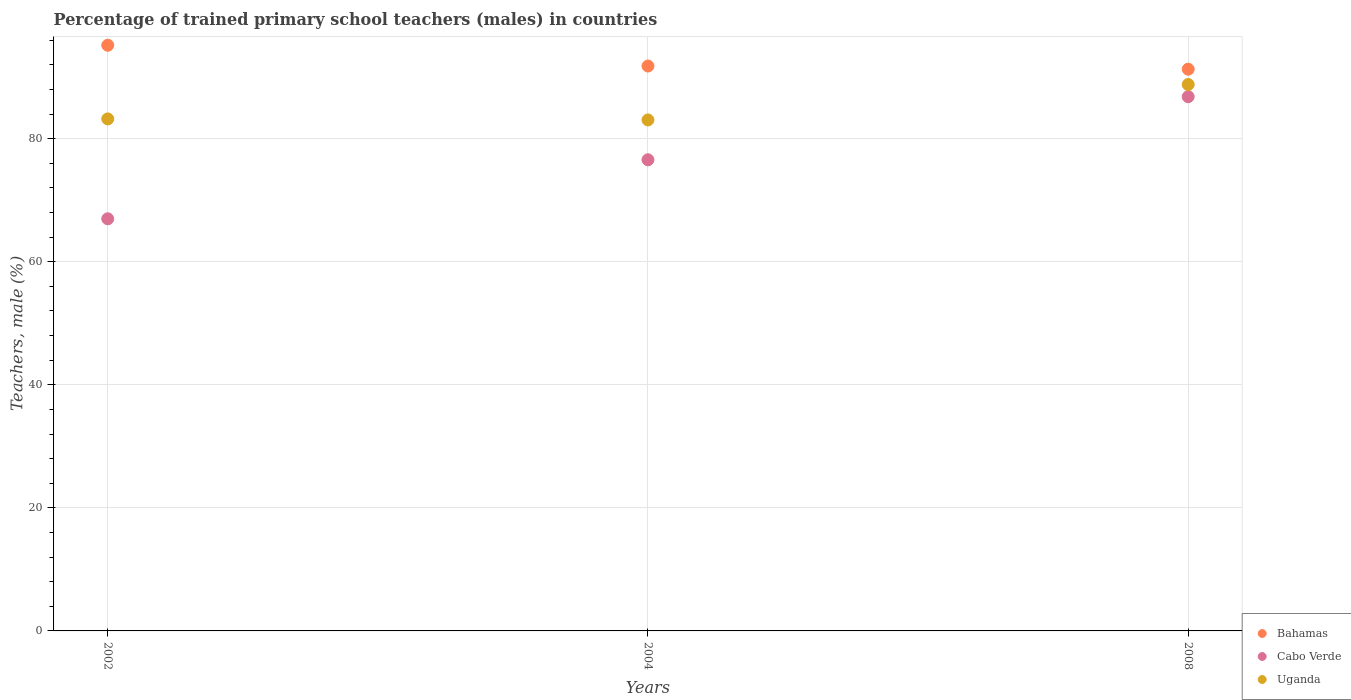What is the percentage of trained primary school teachers (males) in Cabo Verde in 2008?
Provide a succinct answer. 86.83. Across all years, what is the maximum percentage of trained primary school teachers (males) in Bahamas?
Offer a very short reply. 95.19. Across all years, what is the minimum percentage of trained primary school teachers (males) in Uganda?
Make the answer very short. 83.05. In which year was the percentage of trained primary school teachers (males) in Bahamas maximum?
Keep it short and to the point. 2002. In which year was the percentage of trained primary school teachers (males) in Uganda minimum?
Offer a very short reply. 2004. What is the total percentage of trained primary school teachers (males) in Cabo Verde in the graph?
Offer a very short reply. 230.38. What is the difference between the percentage of trained primary school teachers (males) in Uganda in 2002 and that in 2004?
Offer a terse response. 0.17. What is the difference between the percentage of trained primary school teachers (males) in Cabo Verde in 2004 and the percentage of trained primary school teachers (males) in Bahamas in 2002?
Give a very brief answer. -18.61. What is the average percentage of trained primary school teachers (males) in Cabo Verde per year?
Offer a very short reply. 76.79. In the year 2008, what is the difference between the percentage of trained primary school teachers (males) in Cabo Verde and percentage of trained primary school teachers (males) in Uganda?
Ensure brevity in your answer.  -1.98. In how many years, is the percentage of trained primary school teachers (males) in Bahamas greater than 64 %?
Ensure brevity in your answer.  3. What is the ratio of the percentage of trained primary school teachers (males) in Cabo Verde in 2002 to that in 2008?
Your response must be concise. 0.77. Is the percentage of trained primary school teachers (males) in Bahamas in 2004 less than that in 2008?
Ensure brevity in your answer.  No. Is the difference between the percentage of trained primary school teachers (males) in Cabo Verde in 2002 and 2004 greater than the difference between the percentage of trained primary school teachers (males) in Uganda in 2002 and 2004?
Provide a short and direct response. No. What is the difference between the highest and the second highest percentage of trained primary school teachers (males) in Uganda?
Provide a succinct answer. 5.59. What is the difference between the highest and the lowest percentage of trained primary school teachers (males) in Uganda?
Provide a succinct answer. 5.76. Is the sum of the percentage of trained primary school teachers (males) in Bahamas in 2002 and 2004 greater than the maximum percentage of trained primary school teachers (males) in Uganda across all years?
Offer a very short reply. Yes. Is it the case that in every year, the sum of the percentage of trained primary school teachers (males) in Cabo Verde and percentage of trained primary school teachers (males) in Bahamas  is greater than the percentage of trained primary school teachers (males) in Uganda?
Offer a very short reply. Yes. Is the percentage of trained primary school teachers (males) in Bahamas strictly greater than the percentage of trained primary school teachers (males) in Uganda over the years?
Offer a very short reply. Yes. Is the percentage of trained primary school teachers (males) in Cabo Verde strictly less than the percentage of trained primary school teachers (males) in Bahamas over the years?
Offer a very short reply. Yes. How many years are there in the graph?
Offer a very short reply. 3. What is the difference between two consecutive major ticks on the Y-axis?
Your answer should be very brief. 20. Are the values on the major ticks of Y-axis written in scientific E-notation?
Offer a terse response. No. Does the graph contain any zero values?
Provide a succinct answer. No. How are the legend labels stacked?
Give a very brief answer. Vertical. What is the title of the graph?
Offer a terse response. Percentage of trained primary school teachers (males) in countries. Does "Cabo Verde" appear as one of the legend labels in the graph?
Make the answer very short. Yes. What is the label or title of the X-axis?
Offer a terse response. Years. What is the label or title of the Y-axis?
Your answer should be very brief. Teachers, male (%). What is the Teachers, male (%) of Bahamas in 2002?
Keep it short and to the point. 95.19. What is the Teachers, male (%) in Cabo Verde in 2002?
Your response must be concise. 66.98. What is the Teachers, male (%) of Uganda in 2002?
Make the answer very short. 83.21. What is the Teachers, male (%) in Bahamas in 2004?
Provide a short and direct response. 91.81. What is the Teachers, male (%) in Cabo Verde in 2004?
Your answer should be compact. 76.57. What is the Teachers, male (%) of Uganda in 2004?
Ensure brevity in your answer.  83.05. What is the Teachers, male (%) of Bahamas in 2008?
Provide a succinct answer. 91.29. What is the Teachers, male (%) in Cabo Verde in 2008?
Provide a short and direct response. 86.83. What is the Teachers, male (%) of Uganda in 2008?
Provide a short and direct response. 88.81. Across all years, what is the maximum Teachers, male (%) of Bahamas?
Offer a terse response. 95.19. Across all years, what is the maximum Teachers, male (%) of Cabo Verde?
Provide a short and direct response. 86.83. Across all years, what is the maximum Teachers, male (%) of Uganda?
Keep it short and to the point. 88.81. Across all years, what is the minimum Teachers, male (%) of Bahamas?
Offer a very short reply. 91.29. Across all years, what is the minimum Teachers, male (%) in Cabo Verde?
Make the answer very short. 66.98. Across all years, what is the minimum Teachers, male (%) in Uganda?
Offer a terse response. 83.05. What is the total Teachers, male (%) in Bahamas in the graph?
Ensure brevity in your answer.  278.29. What is the total Teachers, male (%) of Cabo Verde in the graph?
Your answer should be compact. 230.38. What is the total Teachers, male (%) of Uganda in the graph?
Ensure brevity in your answer.  255.07. What is the difference between the Teachers, male (%) in Bahamas in 2002 and that in 2004?
Ensure brevity in your answer.  3.38. What is the difference between the Teachers, male (%) of Cabo Verde in 2002 and that in 2004?
Make the answer very short. -9.59. What is the difference between the Teachers, male (%) in Uganda in 2002 and that in 2004?
Your response must be concise. 0.17. What is the difference between the Teachers, male (%) in Bahamas in 2002 and that in 2008?
Give a very brief answer. 3.89. What is the difference between the Teachers, male (%) in Cabo Verde in 2002 and that in 2008?
Provide a succinct answer. -19.85. What is the difference between the Teachers, male (%) of Uganda in 2002 and that in 2008?
Your response must be concise. -5.59. What is the difference between the Teachers, male (%) of Bahamas in 2004 and that in 2008?
Provide a short and direct response. 0.51. What is the difference between the Teachers, male (%) in Cabo Verde in 2004 and that in 2008?
Give a very brief answer. -10.26. What is the difference between the Teachers, male (%) in Uganda in 2004 and that in 2008?
Your answer should be compact. -5.76. What is the difference between the Teachers, male (%) of Bahamas in 2002 and the Teachers, male (%) of Cabo Verde in 2004?
Offer a very short reply. 18.61. What is the difference between the Teachers, male (%) in Bahamas in 2002 and the Teachers, male (%) in Uganda in 2004?
Offer a very short reply. 12.14. What is the difference between the Teachers, male (%) in Cabo Verde in 2002 and the Teachers, male (%) in Uganda in 2004?
Keep it short and to the point. -16.07. What is the difference between the Teachers, male (%) of Bahamas in 2002 and the Teachers, male (%) of Cabo Verde in 2008?
Your response must be concise. 8.36. What is the difference between the Teachers, male (%) of Bahamas in 2002 and the Teachers, male (%) of Uganda in 2008?
Make the answer very short. 6.38. What is the difference between the Teachers, male (%) in Cabo Verde in 2002 and the Teachers, male (%) in Uganda in 2008?
Offer a very short reply. -21.83. What is the difference between the Teachers, male (%) in Bahamas in 2004 and the Teachers, male (%) in Cabo Verde in 2008?
Your answer should be compact. 4.98. What is the difference between the Teachers, male (%) of Bahamas in 2004 and the Teachers, male (%) of Uganda in 2008?
Provide a succinct answer. 3. What is the difference between the Teachers, male (%) in Cabo Verde in 2004 and the Teachers, male (%) in Uganda in 2008?
Provide a short and direct response. -12.23. What is the average Teachers, male (%) of Bahamas per year?
Offer a terse response. 92.76. What is the average Teachers, male (%) of Cabo Verde per year?
Offer a terse response. 76.79. What is the average Teachers, male (%) of Uganda per year?
Give a very brief answer. 85.02. In the year 2002, what is the difference between the Teachers, male (%) in Bahamas and Teachers, male (%) in Cabo Verde?
Provide a succinct answer. 28.2. In the year 2002, what is the difference between the Teachers, male (%) in Bahamas and Teachers, male (%) in Uganda?
Ensure brevity in your answer.  11.97. In the year 2002, what is the difference between the Teachers, male (%) of Cabo Verde and Teachers, male (%) of Uganda?
Offer a very short reply. -16.23. In the year 2004, what is the difference between the Teachers, male (%) of Bahamas and Teachers, male (%) of Cabo Verde?
Provide a short and direct response. 15.23. In the year 2004, what is the difference between the Teachers, male (%) in Bahamas and Teachers, male (%) in Uganda?
Provide a short and direct response. 8.76. In the year 2004, what is the difference between the Teachers, male (%) of Cabo Verde and Teachers, male (%) of Uganda?
Your response must be concise. -6.47. In the year 2008, what is the difference between the Teachers, male (%) of Bahamas and Teachers, male (%) of Cabo Verde?
Give a very brief answer. 4.46. In the year 2008, what is the difference between the Teachers, male (%) of Bahamas and Teachers, male (%) of Uganda?
Provide a short and direct response. 2.49. In the year 2008, what is the difference between the Teachers, male (%) of Cabo Verde and Teachers, male (%) of Uganda?
Offer a terse response. -1.98. What is the ratio of the Teachers, male (%) of Bahamas in 2002 to that in 2004?
Keep it short and to the point. 1.04. What is the ratio of the Teachers, male (%) in Cabo Verde in 2002 to that in 2004?
Provide a succinct answer. 0.87. What is the ratio of the Teachers, male (%) of Uganda in 2002 to that in 2004?
Your answer should be compact. 1. What is the ratio of the Teachers, male (%) of Bahamas in 2002 to that in 2008?
Offer a terse response. 1.04. What is the ratio of the Teachers, male (%) of Cabo Verde in 2002 to that in 2008?
Give a very brief answer. 0.77. What is the ratio of the Teachers, male (%) of Uganda in 2002 to that in 2008?
Keep it short and to the point. 0.94. What is the ratio of the Teachers, male (%) in Bahamas in 2004 to that in 2008?
Provide a succinct answer. 1.01. What is the ratio of the Teachers, male (%) in Cabo Verde in 2004 to that in 2008?
Your answer should be very brief. 0.88. What is the ratio of the Teachers, male (%) of Uganda in 2004 to that in 2008?
Give a very brief answer. 0.94. What is the difference between the highest and the second highest Teachers, male (%) of Bahamas?
Offer a very short reply. 3.38. What is the difference between the highest and the second highest Teachers, male (%) of Cabo Verde?
Your response must be concise. 10.26. What is the difference between the highest and the second highest Teachers, male (%) of Uganda?
Your answer should be compact. 5.59. What is the difference between the highest and the lowest Teachers, male (%) of Bahamas?
Your answer should be compact. 3.89. What is the difference between the highest and the lowest Teachers, male (%) of Cabo Verde?
Offer a very short reply. 19.85. What is the difference between the highest and the lowest Teachers, male (%) in Uganda?
Offer a terse response. 5.76. 